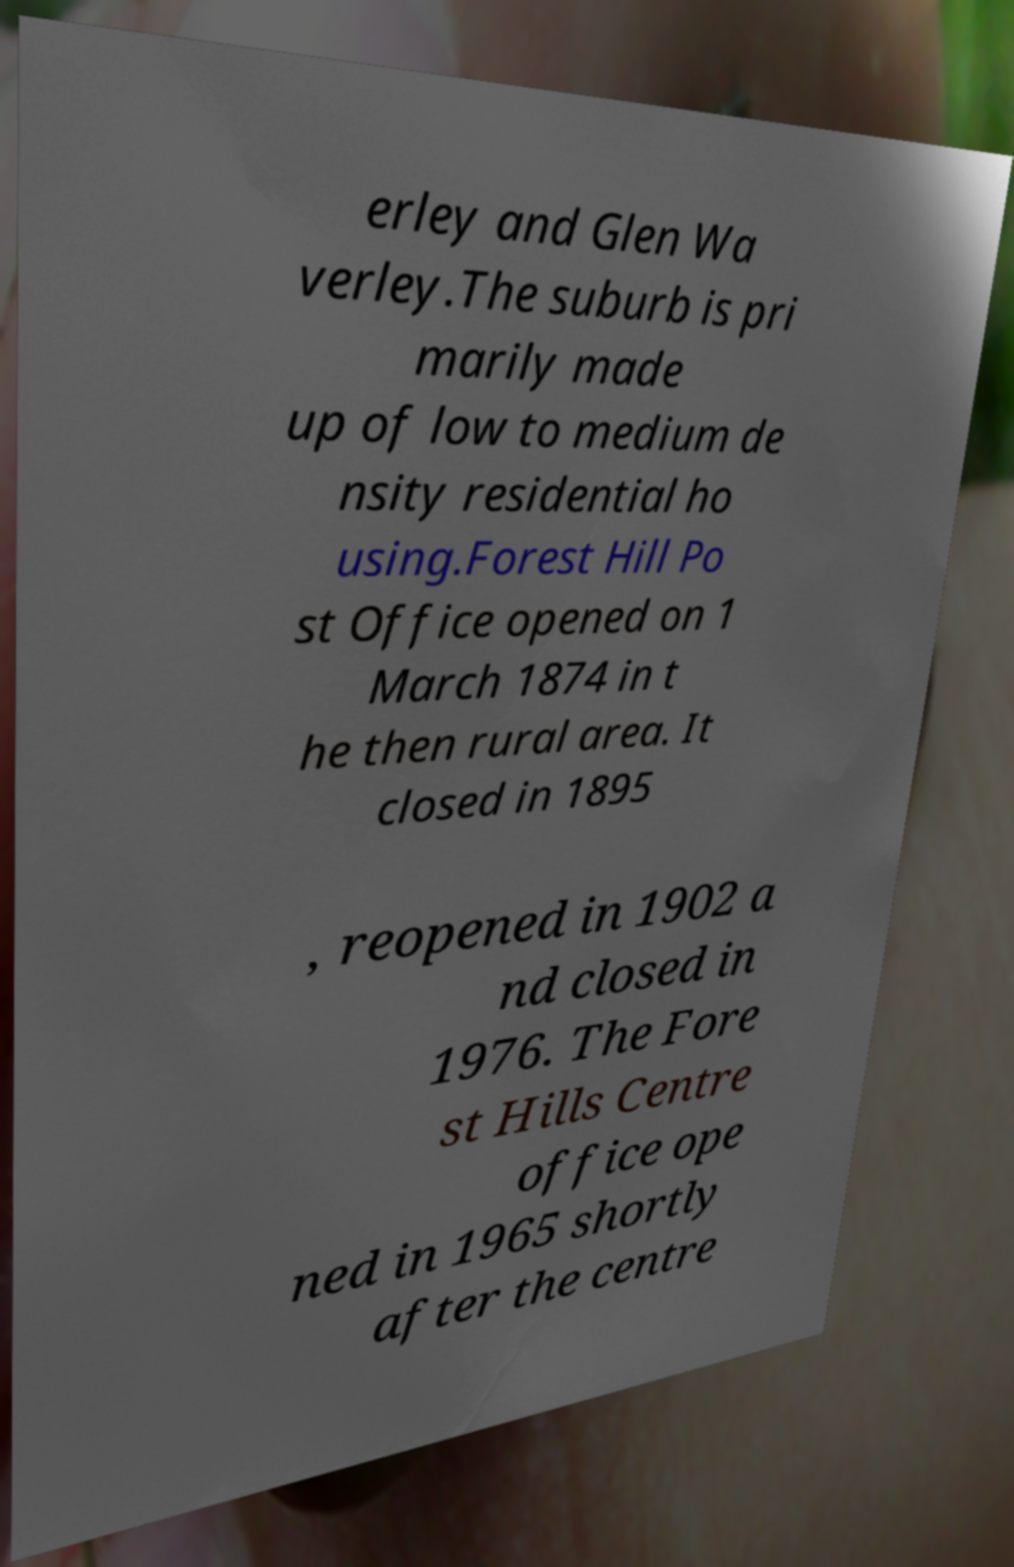Can you read and provide the text displayed in the image?This photo seems to have some interesting text. Can you extract and type it out for me? erley and Glen Wa verley.The suburb is pri marily made up of low to medium de nsity residential ho using.Forest Hill Po st Office opened on 1 March 1874 in t he then rural area. It closed in 1895 , reopened in 1902 a nd closed in 1976. The Fore st Hills Centre office ope ned in 1965 shortly after the centre 